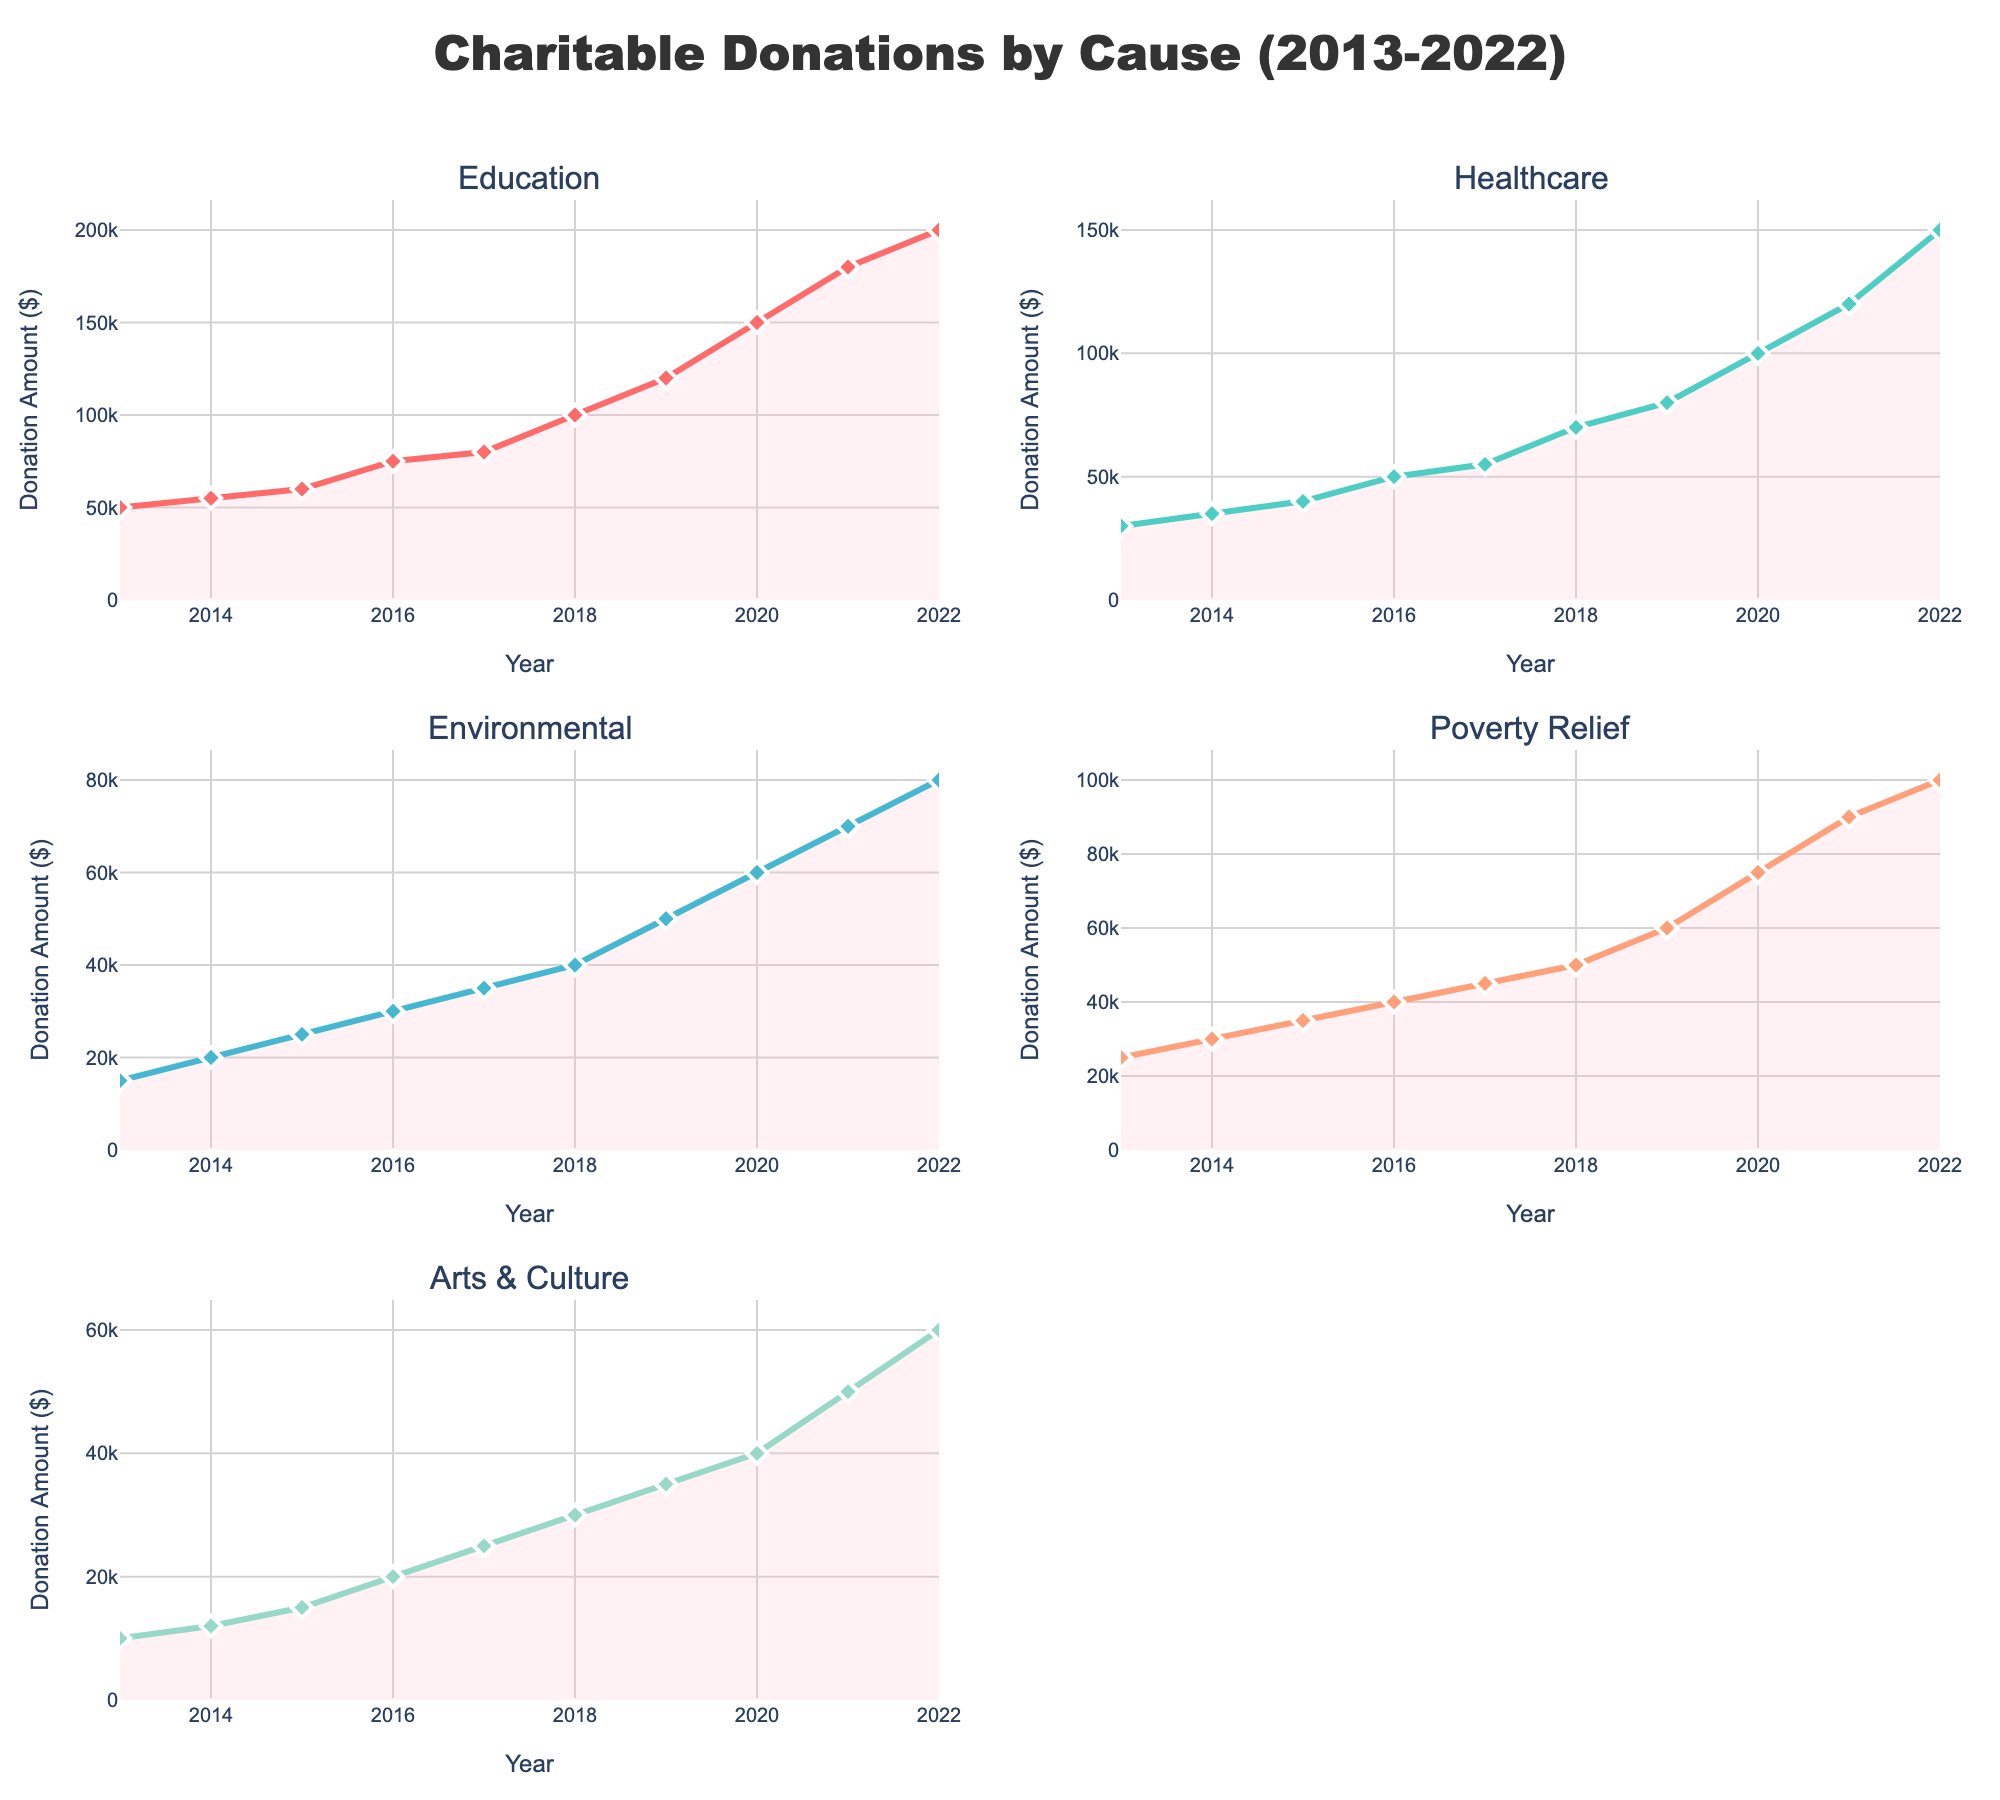What is the title of the figure? The title is located at the top of the figure and stands out due to its larger font size and central positioning.
Answer: Percentage of Plants Sold by Sunlight Requirements What are the labels used in each pie chart to represent the sunlight requirements? The labels are visually displayed on each pie chart, annotated with percentages and text.
Answer: Full Sun, Partial Shade, Full Shade Which plant category has the highest percentage of plants sold for "Full Sun"? Observe the segments of each pie chart labeled "Full Sun" and identify the one with the largest size.
Answer: Vegetables By how many percentage points does the "Full Sun" requirement for Herbs exceed that of Annuals? Find the "Full Sun" percentage for both Herbs (65%) and Annuals (50%), then subtract the latter from the former (65% - 50%).
Answer: 15% What is the combined percentage for "Partial Shade" and "Full Shade" for Perennials? Sum the percentages for "Partial Shade" (35%) and "Full Shade" (20%) for Perennials from the relevant pie chart (35% + 20%).
Answer: 55% Which plant category has the most evenly distributed sunlight requirements? Compare the pie charts to see the one with the closest proportions for "Full Sun," "Partial Shade," and "Full Shade."
Answer: Annuals How much higher is the "Full Shade" percentage of Perennials compared to Vegetables? Locate the "Full Shade" percentage for both Perennials (20%) and Vegetables (5%), then calculate the difference (20% - 5%).
Answer: 15% How many plant categories have a "Full Sun" requirement making up more than half of their sales? Count the number of pie charts where the "Full Sun" section represents over 50%.
Answer: 4 (Shrubs, Trees, Herbs, Vegetables) 